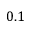<formula> <loc_0><loc_0><loc_500><loc_500>0 . 1</formula> 